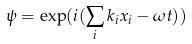<formula> <loc_0><loc_0><loc_500><loc_500>\psi = \exp ( i ( \sum _ { i } k _ { i } x _ { i } - \omega t ) )</formula> 